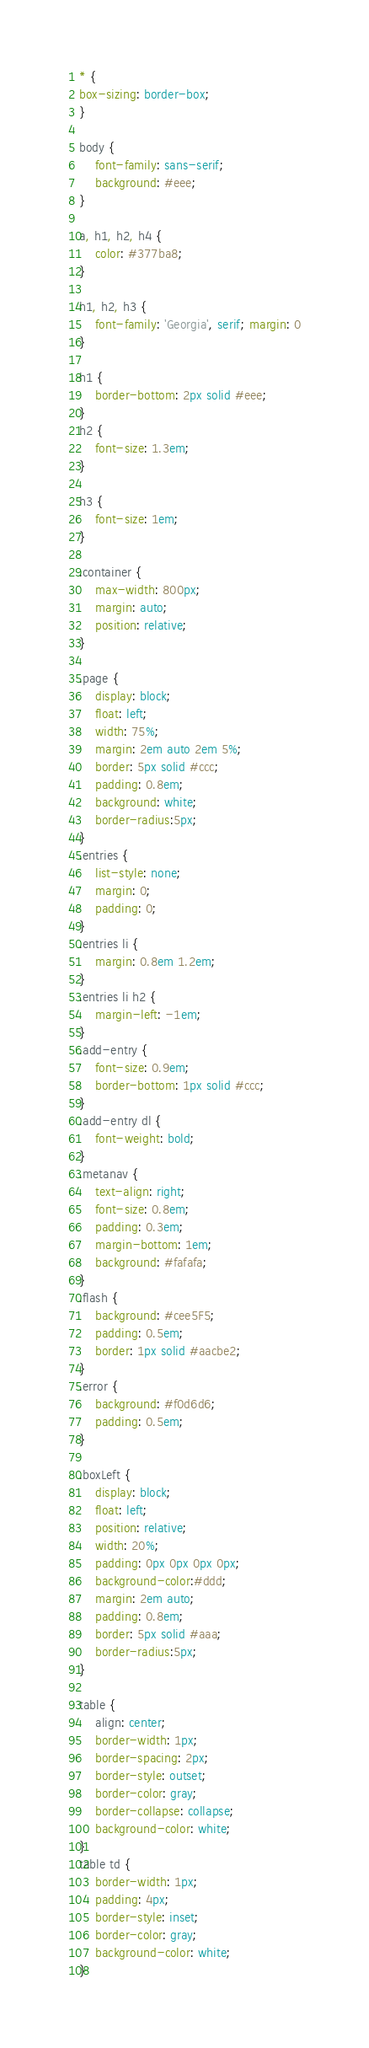<code> <loc_0><loc_0><loc_500><loc_500><_CSS_>* {
box-sizing: border-box;
}

body {
	font-family: sans-serif;
	background: #eee;
}

a, h1, h2, h4 {
	color: #377ba8;
}

h1, h2, h3 {
	font-family: 'Georgia', serif; margin: 0
}

h1 {
	border-bottom: 2px solid #eee;
}
h2 {
	font-size: 1.3em;
}

h3 {
	font-size: 1em;
}

.container {
	max-width: 800px;
	margin: auto;
	position: relative;
}

.page {
	display: block;
	float: left;
	width: 75%;
	margin: 2em auto 2em 5%;
	border: 5px solid #ccc;
	padding: 0.8em;
	background: white;
	border-radius:5px;
}
.entries {
	list-style: none;
	margin: 0;
	padding: 0;
}
.entries li {
	margin: 0.8em 1.2em;
}
.entries li h2 {
	margin-left: -1em;
}
.add-entry {
	font-size: 0.9em;
	border-bottom: 1px solid #ccc;
}
.add-entry dl {
	font-weight: bold;
}
.metanav {
	text-align: right;
	font-size: 0.8em;
	padding: 0.3em;
	margin-bottom: 1em;
	background: #fafafa;
}
.flash {
	background: #cee5F5;
	padding: 0.5em;
	border: 1px solid #aacbe2;
}
.error {
	background: #f0d6d6;
	padding: 0.5em;
}

.boxLeft {
	display: block;
	float: left;
	position: relative;
	width: 20%;
	padding: 0px 0px 0px 0px;
	background-color:#ddd;
	margin: 2em auto;
	padding: 0.8em;
	border: 5px solid #aaa;
	border-radius:5px;
}

table {
	align: center;
	border-width: 1px;
	border-spacing: 2px;
	border-style: outset;
	border-color: gray;
	border-collapse: collapse;
	background-color: white;
}
table td {
	border-width: 1px;
	padding: 4px;
	border-style: inset;
	border-color: gray;
	background-color: white;
}
</code> 